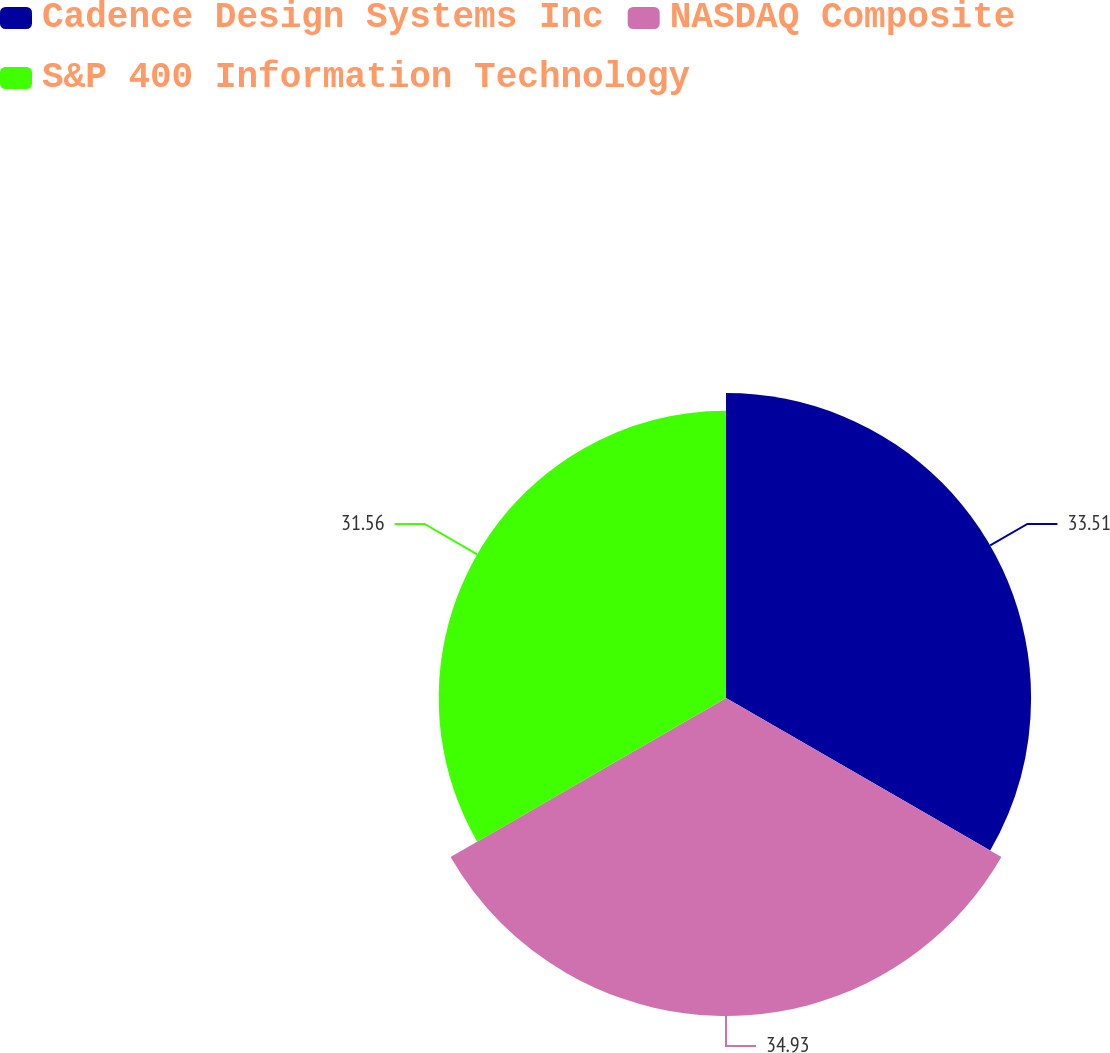Convert chart. <chart><loc_0><loc_0><loc_500><loc_500><pie_chart><fcel>Cadence Design Systems Inc<fcel>NASDAQ Composite<fcel>S&P 400 Information Technology<nl><fcel>33.51%<fcel>34.93%<fcel>31.56%<nl></chart> 